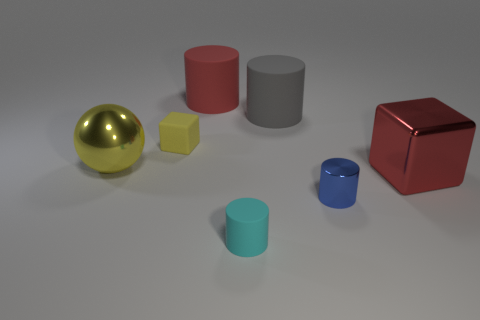Add 1 big green cylinders. How many objects exist? 8 Subtract all cylinders. How many objects are left? 3 Add 4 tiny metal objects. How many tiny metal objects are left? 5 Add 7 big yellow balls. How many big yellow balls exist? 8 Subtract 0 gray spheres. How many objects are left? 7 Subtract all small purple things. Subtract all tiny matte cylinders. How many objects are left? 6 